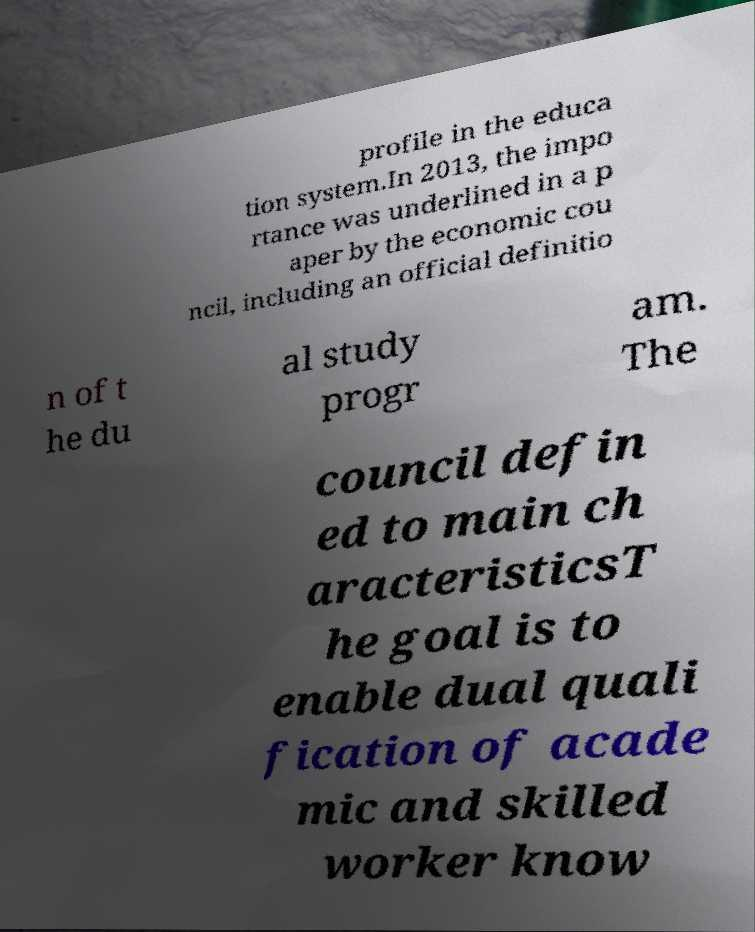What messages or text are displayed in this image? I need them in a readable, typed format. profile in the educa tion system.In 2013, the impo rtance was underlined in a p aper by the economic cou ncil, including an official definitio n of t he du al study progr am. The council defin ed to main ch aracteristicsT he goal is to enable dual quali fication of acade mic and skilled worker know 